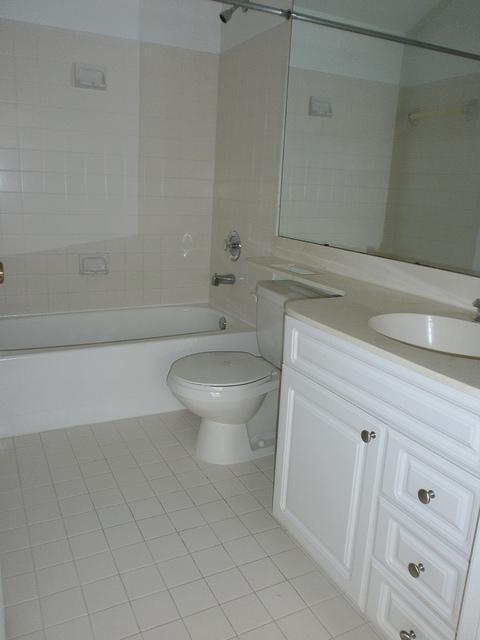How many cats do you see?
Give a very brief answer. 0. How many diamond shapes are here?
Give a very brief answer. 0. How many shelf handles are in this picture?
Give a very brief answer. 4. How many towels are hanging on the towel rack?
Give a very brief answer. 0. How many sinks are in this image?
Give a very brief answer. 1. 